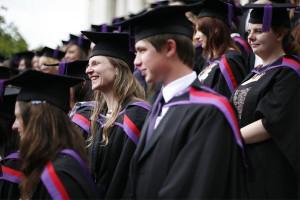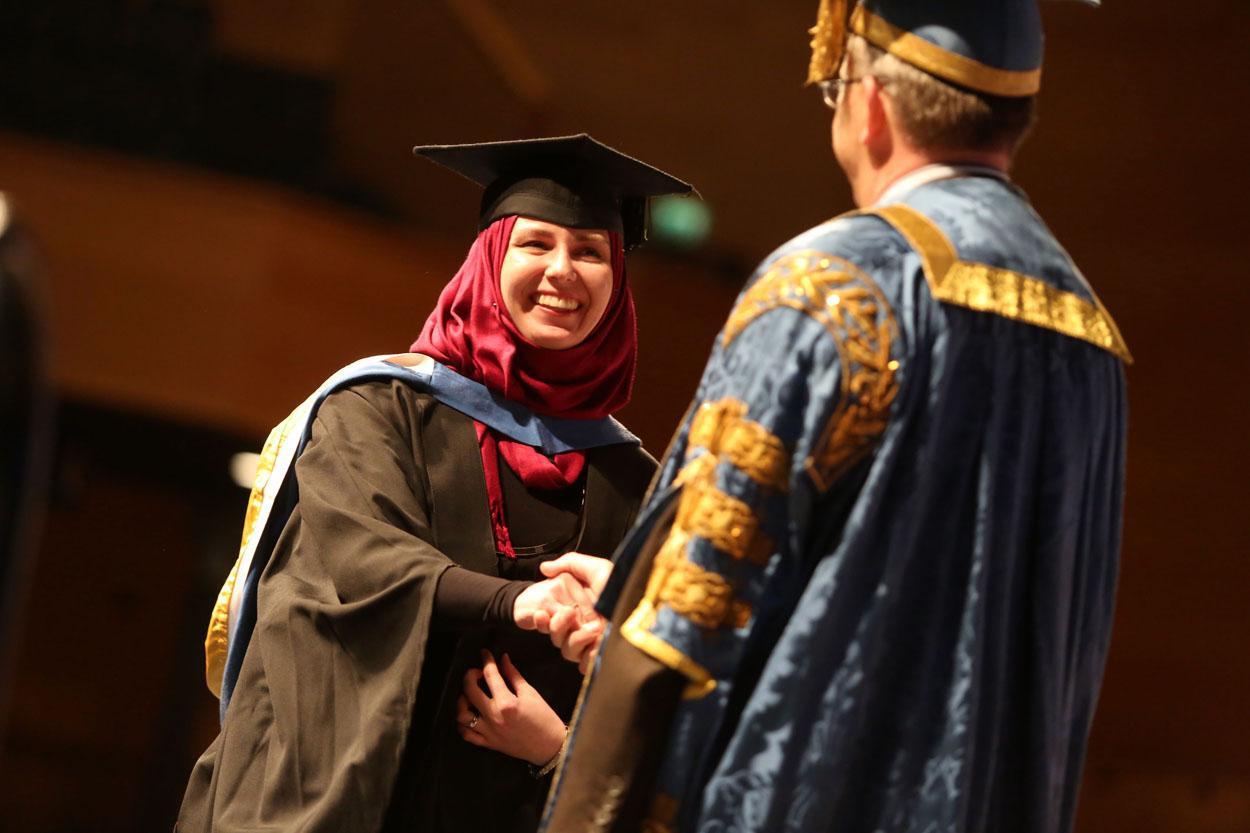The first image is the image on the left, the second image is the image on the right. Given the left and right images, does the statement "Two people, a woman and a man, are wearing graduation attire in the image on the right." hold true? Answer yes or no. Yes. The first image is the image on the left, the second image is the image on the right. Assess this claim about the two images: "An image shows two side-by-side camera-facing graduates who together hold up a single object in front of them.". Correct or not? Answer yes or no. No. 